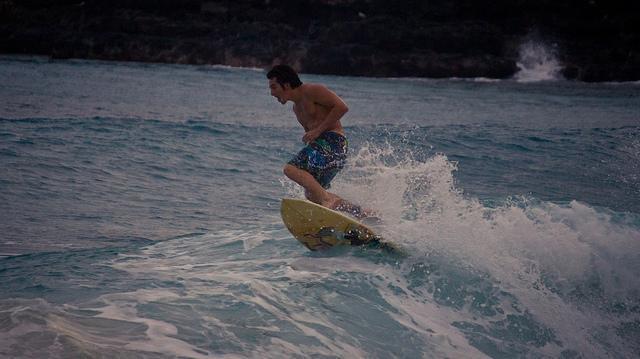How many surfboards can be seen?
Give a very brief answer. 1. How many sinks are next to the toilet?
Give a very brief answer. 0. 